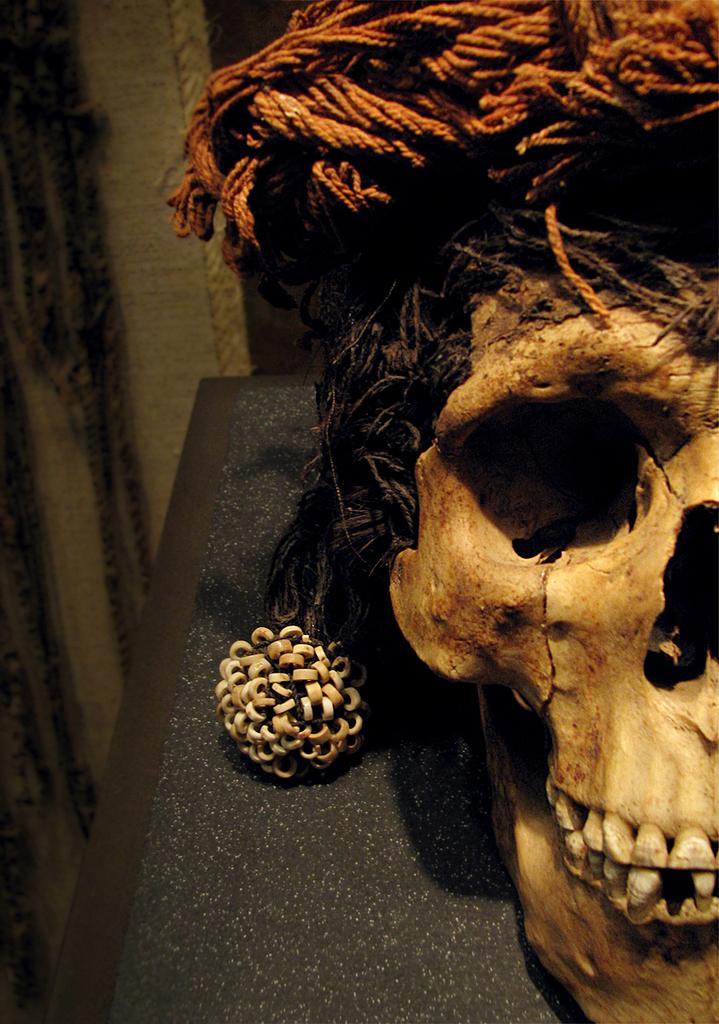Describe this image in one or two sentences. In this image I can see yellow colour skull and few other things. 